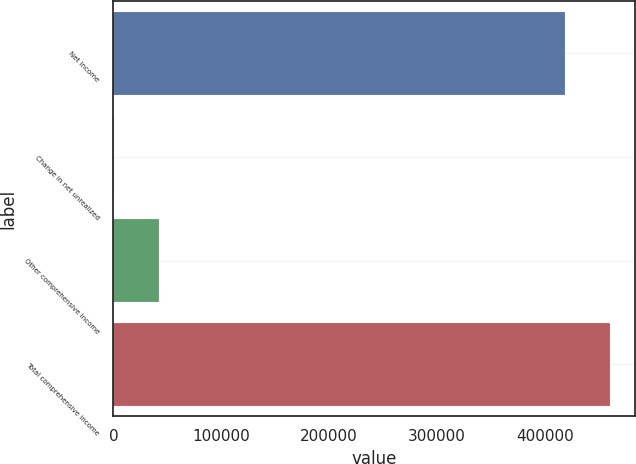Convert chart. <chart><loc_0><loc_0><loc_500><loc_500><bar_chart><fcel>Net income<fcel>Change in net unrealized<fcel>Other comprehensive income<fcel>Total comprehensive income<nl><fcel>418950<fcel>325<fcel>42220<fcel>460845<nl></chart> 